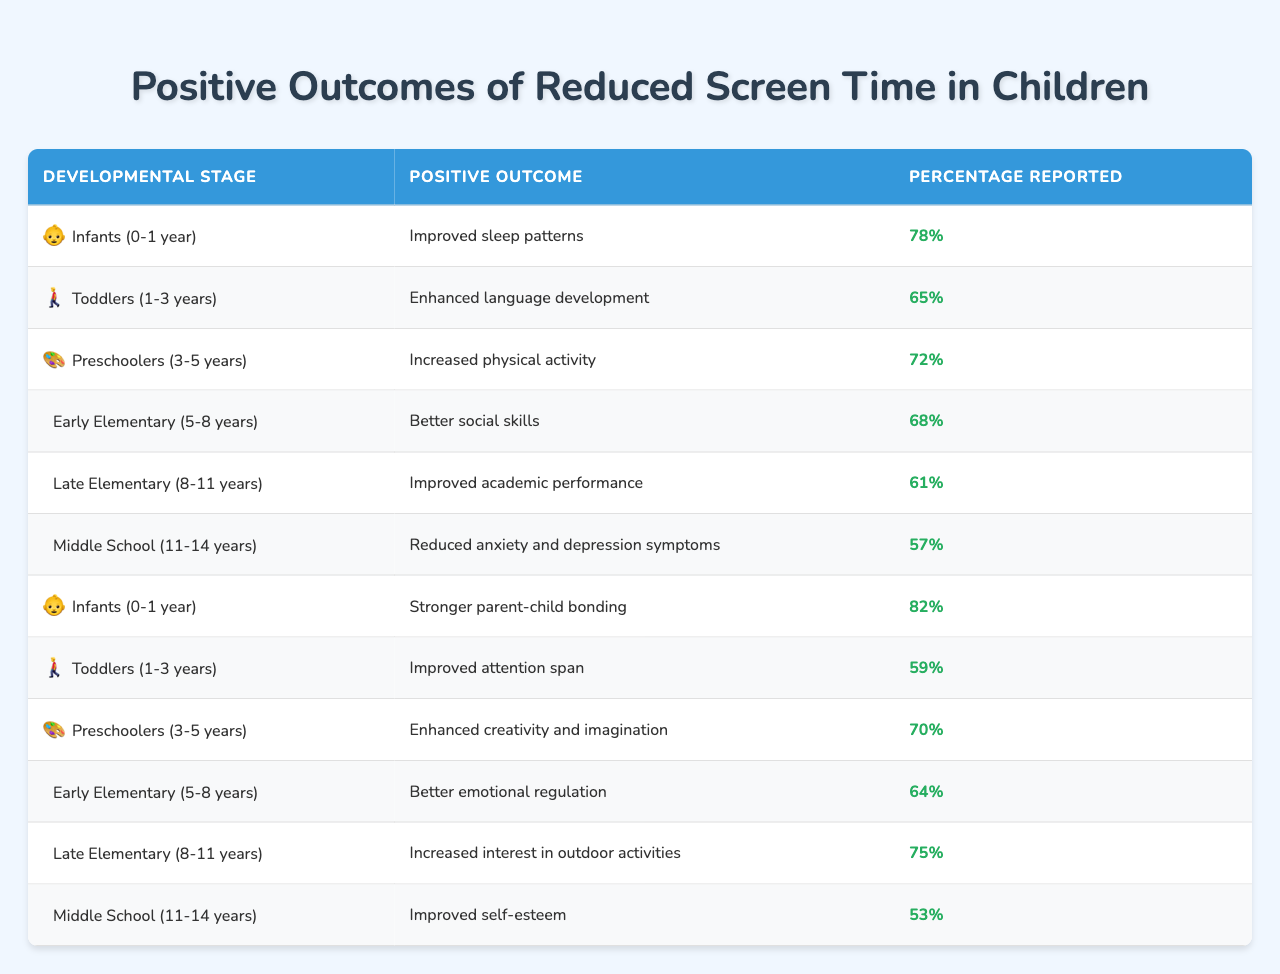What is the positive outcome reported for infants regarding reduced screen time? The table lists two positive outcomes for infants: "Improved sleep patterns" reported by 78% and "Stronger parent-child bonding" reported by 82%.
Answer: Improved sleep patterns and stronger parent-child bonding Which developmental stage shows the highest percentage for improved parent-child bonding? The table indicates that "Stronger parent-child bonding" for infants (0-1 year) has a 82% report percentage, which is the highest compared to other stages.
Answer: Infants (0-1 year) What percentage of middle school children reported improved self-esteem due to reduced screen time? The table shows that for middle school children (11-14 years), the reported percentage for improved self-esteem is 53%.
Answer: 53% Which positive outcome experienced the least percentage of reported benefit in late elementary children? Among late elementary children, "Improved academic performance" is reported at 61%, which is the lowest for that developmental stage compared to the other benefits listed.
Answer: Improved academic performance at 61% What is the difference between the reported percentages of enhanced language development in toddlers and better social skills in early elementary children? For toddlers, enhanced language development is reported at 65%, while better social skills in early elementary are at 68%. The difference is 68 - 65 = 3%.
Answer: 3% What are the two outcomes reported for preschoolers, and how do their percentages compare? The outcomes for preschoolers are "Increased physical activity" at 72% and "Enhanced creativity and imagination" at 70%. The difference in percentage between the two is 2%.
Answer: Increased physical activity at 72% and enhanced creativity at 70%, a 2% difference Based on the table, what would you expect for the percentage of improved attention span in toddlers compared to other positive outcomes? The table shows that the percentage for improved attention span in toddlers is 59%, which is lower than the highest reported outcomes for infants (82%) and preschoolers (72%). This indicates they generally have fewer positive reported outcomes.
Answer: Lower than other outcomes Is it true that the percentage of children in middle school reporting reduced anxiety and depression symptoms is greater than that for improved academic performance in late elementary children? The table states that reduced anxiety and depression symptoms in middle school are reported at 57%, while improved academic performance in late elementary is reported at 61%. Since 57% is less than 61%, the statement is false.
Answer: No What is the average percentage of reported positive outcomes across all developmental stages listed? To calculate the average, add all percentages (78 + 65 + 72 + 68 + 61 + 57 + 82 + 59 + 70 + 64 + 75 + 53 = 900) and divide by the number of outcomes listed (12). The average is 900 / 12 = 75%.
Answer: 75% Which developmental stage shows the highest overall percentage for reported positive outcomes, and what is that percentage? The highest individual reported percentage is 82% for "Stronger parent-child bonding" in infants, making infants the developmental stage with the highest percentage outcome.
Answer: Infants (82%) 